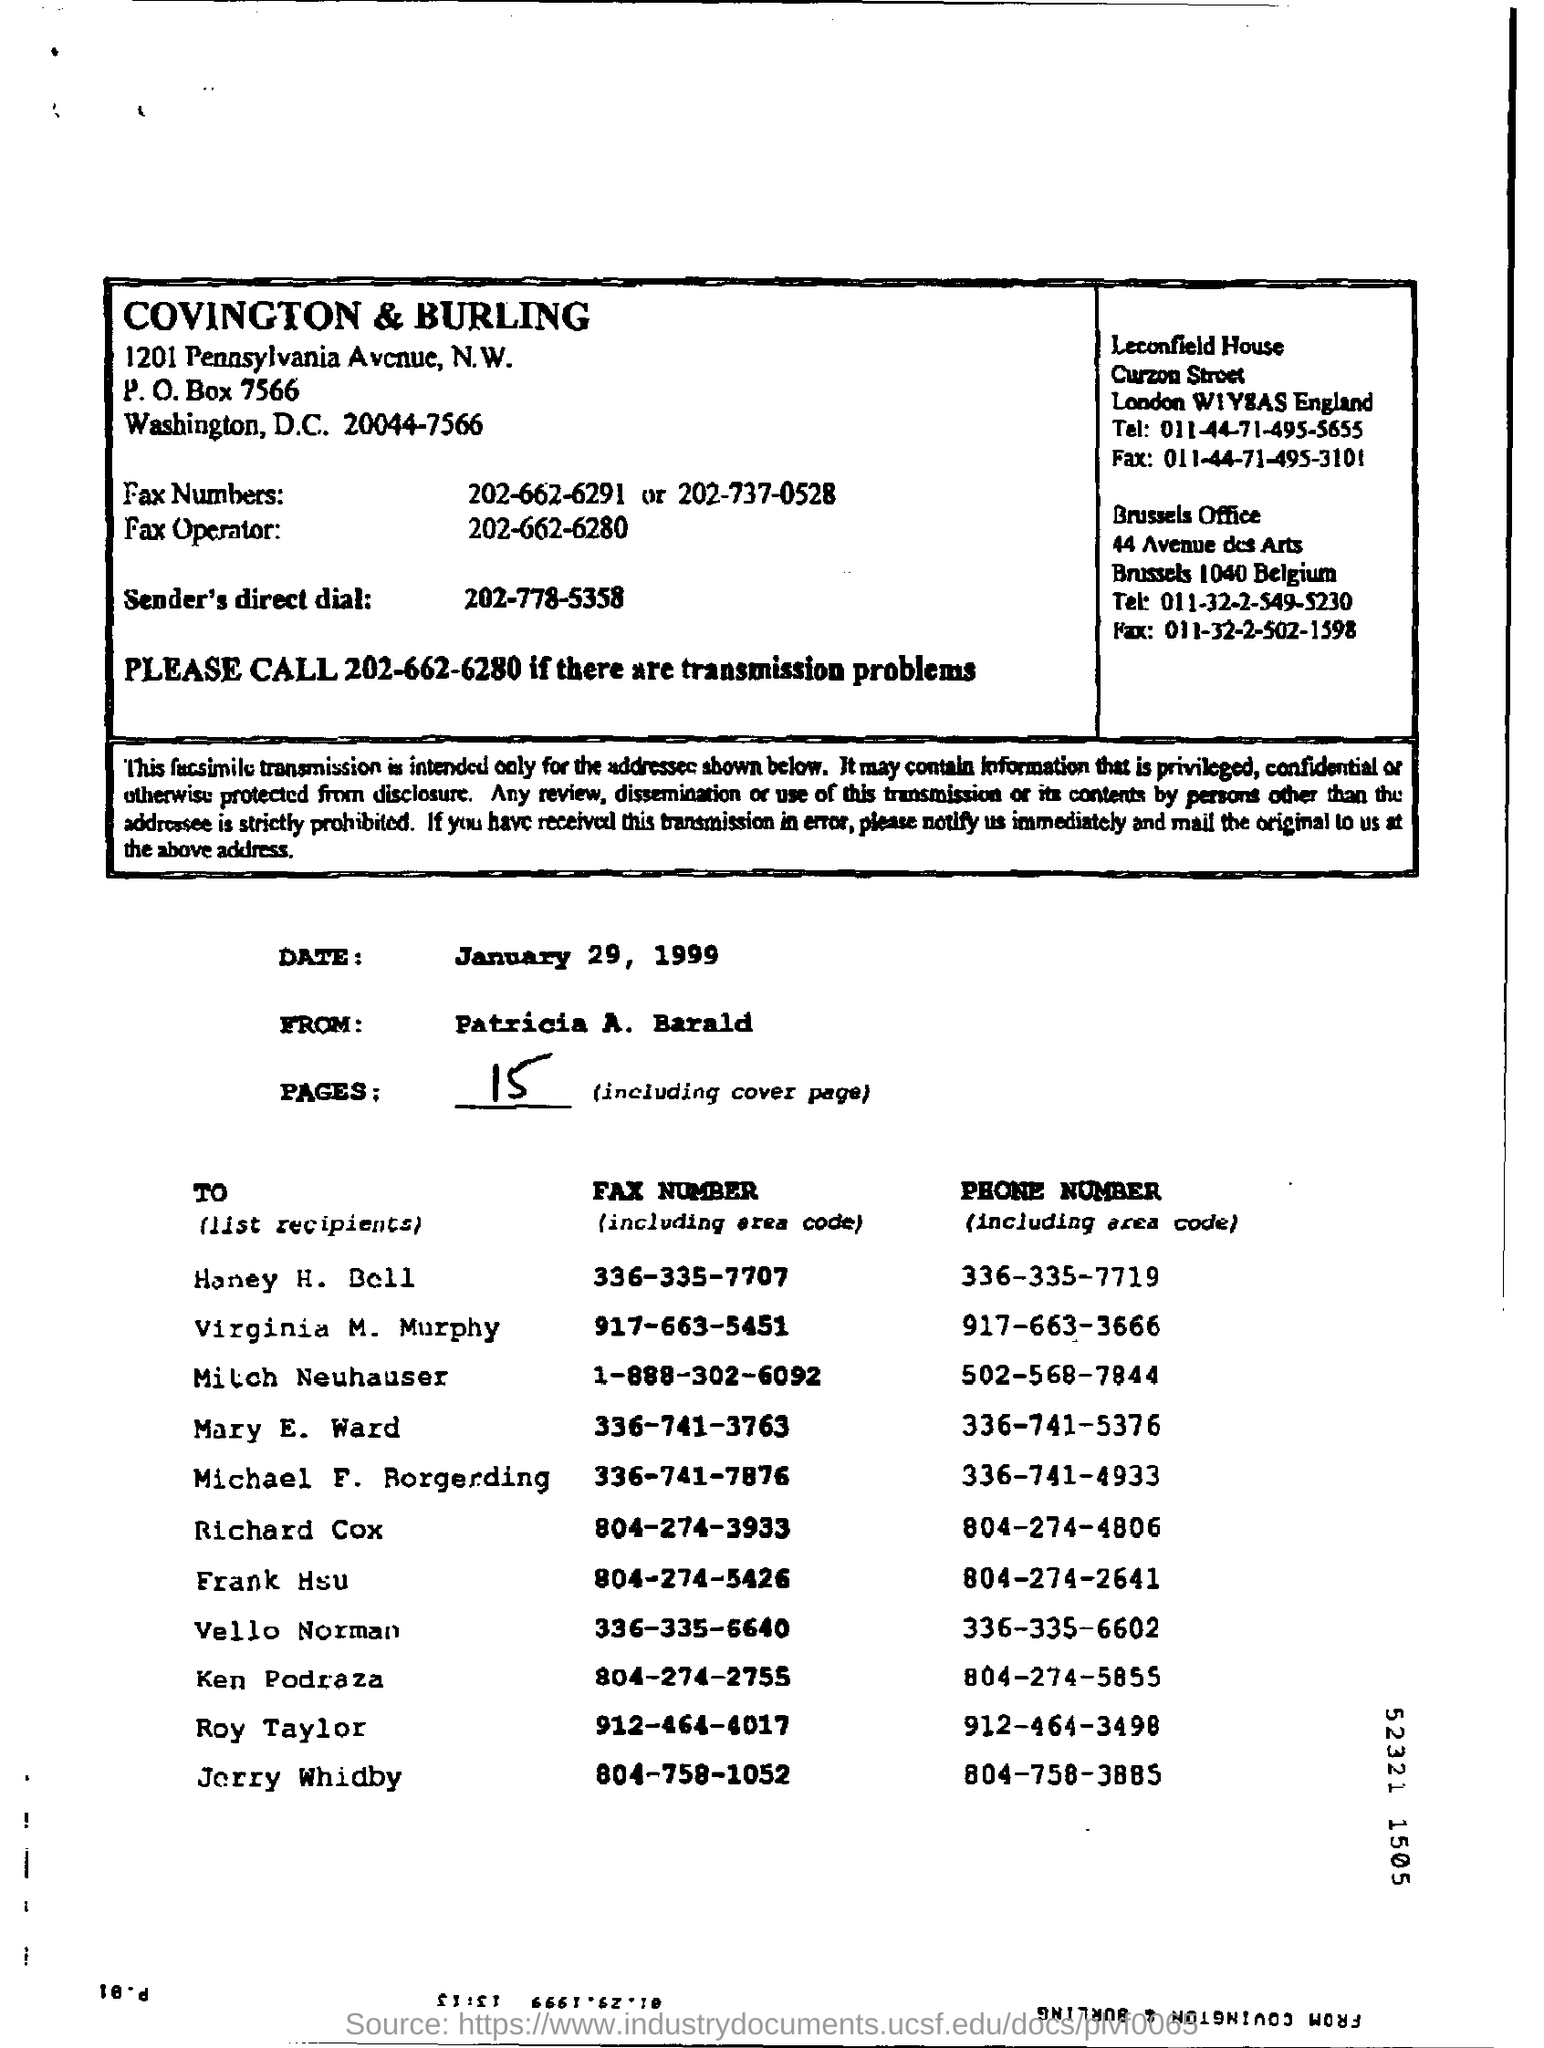Specify some key components in this picture. The phrase "What is sender's direct dial?" is a question asking for an explanation or definition of a specific term or concept. The phone number 202-778-5358 is a contact information for a sender. The total number of pages in the document, including the cover page, is 15. The phone number of Jorry Whidby is 804-758-3885. The speaker is asking for the phone number of Roy Taylor, which is 912-464-3498. The fax number of Honey H Bell is 336-335-7707. 